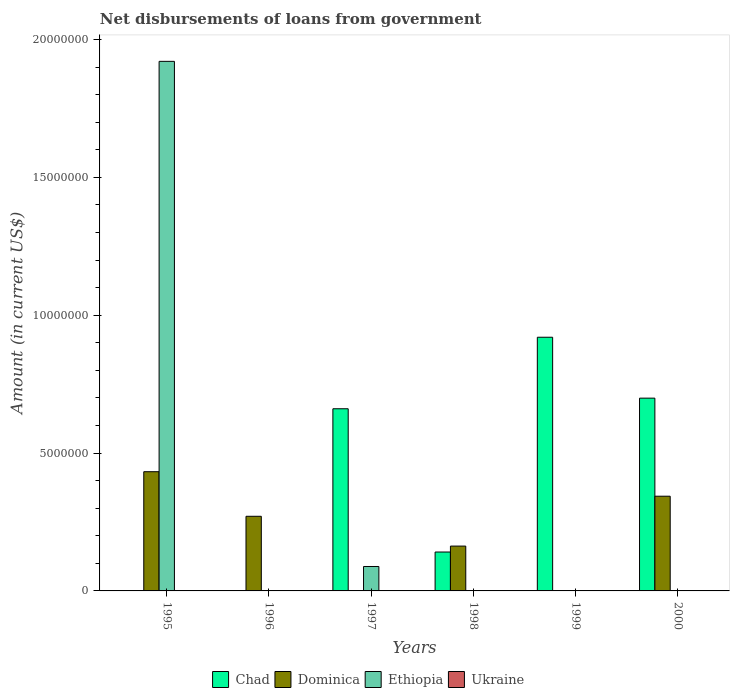Are the number of bars on each tick of the X-axis equal?
Offer a terse response. No. How many bars are there on the 3rd tick from the left?
Provide a short and direct response. 2. How many bars are there on the 1st tick from the right?
Ensure brevity in your answer.  2. What is the label of the 4th group of bars from the left?
Offer a terse response. 1998. What is the amount of loan disbursed from government in Chad in 1997?
Your answer should be compact. 6.61e+06. Across all years, what is the maximum amount of loan disbursed from government in Chad?
Keep it short and to the point. 9.20e+06. Across all years, what is the minimum amount of loan disbursed from government in Ethiopia?
Keep it short and to the point. 0. In which year was the amount of loan disbursed from government in Dominica maximum?
Make the answer very short. 1995. What is the total amount of loan disbursed from government in Ethiopia in the graph?
Make the answer very short. 2.01e+07. What is the difference between the amount of loan disbursed from government in Dominica in 1995 and that in 1996?
Provide a short and direct response. 1.62e+06. In the year 1995, what is the difference between the amount of loan disbursed from government in Ethiopia and amount of loan disbursed from government in Dominica?
Offer a terse response. 1.49e+07. What is the ratio of the amount of loan disbursed from government in Chad in 1999 to that in 2000?
Provide a succinct answer. 1.32. Is the amount of loan disbursed from government in Chad in 1997 less than that in 2000?
Make the answer very short. Yes. What is the difference between the highest and the second highest amount of loan disbursed from government in Dominica?
Provide a short and direct response. 8.89e+05. What is the difference between the highest and the lowest amount of loan disbursed from government in Chad?
Your answer should be very brief. 9.20e+06. Is it the case that in every year, the sum of the amount of loan disbursed from government in Dominica and amount of loan disbursed from government in Ukraine is greater than the sum of amount of loan disbursed from government in Ethiopia and amount of loan disbursed from government in Chad?
Make the answer very short. No. Is it the case that in every year, the sum of the amount of loan disbursed from government in Chad and amount of loan disbursed from government in Dominica is greater than the amount of loan disbursed from government in Ethiopia?
Keep it short and to the point. No. How many bars are there?
Your answer should be very brief. 10. Are all the bars in the graph horizontal?
Offer a very short reply. No. What is the difference between two consecutive major ticks on the Y-axis?
Your response must be concise. 5.00e+06. Does the graph contain any zero values?
Ensure brevity in your answer.  Yes. Where does the legend appear in the graph?
Your answer should be compact. Bottom center. How many legend labels are there?
Offer a terse response. 4. What is the title of the graph?
Ensure brevity in your answer.  Net disbursements of loans from government. Does "Faeroe Islands" appear as one of the legend labels in the graph?
Provide a short and direct response. No. What is the label or title of the Y-axis?
Ensure brevity in your answer.  Amount (in current US$). What is the Amount (in current US$) in Chad in 1995?
Offer a terse response. 0. What is the Amount (in current US$) of Dominica in 1995?
Give a very brief answer. 4.32e+06. What is the Amount (in current US$) of Ethiopia in 1995?
Make the answer very short. 1.92e+07. What is the Amount (in current US$) in Ukraine in 1995?
Your response must be concise. 0. What is the Amount (in current US$) of Chad in 1996?
Your answer should be very brief. 0. What is the Amount (in current US$) in Dominica in 1996?
Your answer should be very brief. 2.71e+06. What is the Amount (in current US$) in Ethiopia in 1996?
Make the answer very short. 0. What is the Amount (in current US$) of Chad in 1997?
Offer a terse response. 6.61e+06. What is the Amount (in current US$) of Ethiopia in 1997?
Give a very brief answer. 8.86e+05. What is the Amount (in current US$) of Ukraine in 1997?
Your answer should be very brief. 0. What is the Amount (in current US$) of Chad in 1998?
Offer a very short reply. 1.41e+06. What is the Amount (in current US$) in Dominica in 1998?
Ensure brevity in your answer.  1.63e+06. What is the Amount (in current US$) of Ukraine in 1998?
Provide a succinct answer. 0. What is the Amount (in current US$) of Chad in 1999?
Your response must be concise. 9.20e+06. What is the Amount (in current US$) of Ethiopia in 1999?
Provide a succinct answer. 0. What is the Amount (in current US$) in Chad in 2000?
Provide a short and direct response. 6.99e+06. What is the Amount (in current US$) of Dominica in 2000?
Offer a very short reply. 3.44e+06. What is the Amount (in current US$) of Ethiopia in 2000?
Provide a succinct answer. 0. What is the Amount (in current US$) of Ukraine in 2000?
Offer a terse response. 0. Across all years, what is the maximum Amount (in current US$) of Chad?
Ensure brevity in your answer.  9.20e+06. Across all years, what is the maximum Amount (in current US$) of Dominica?
Make the answer very short. 4.32e+06. Across all years, what is the maximum Amount (in current US$) of Ethiopia?
Provide a short and direct response. 1.92e+07. Across all years, what is the minimum Amount (in current US$) of Dominica?
Offer a very short reply. 0. Across all years, what is the minimum Amount (in current US$) of Ethiopia?
Provide a succinct answer. 0. What is the total Amount (in current US$) in Chad in the graph?
Keep it short and to the point. 2.42e+07. What is the total Amount (in current US$) of Dominica in the graph?
Make the answer very short. 1.21e+07. What is the total Amount (in current US$) of Ethiopia in the graph?
Give a very brief answer. 2.01e+07. What is the total Amount (in current US$) of Ukraine in the graph?
Your answer should be very brief. 0. What is the difference between the Amount (in current US$) in Dominica in 1995 and that in 1996?
Your answer should be very brief. 1.62e+06. What is the difference between the Amount (in current US$) of Ethiopia in 1995 and that in 1997?
Give a very brief answer. 1.83e+07. What is the difference between the Amount (in current US$) in Dominica in 1995 and that in 1998?
Your response must be concise. 2.70e+06. What is the difference between the Amount (in current US$) of Dominica in 1995 and that in 2000?
Your answer should be very brief. 8.89e+05. What is the difference between the Amount (in current US$) in Dominica in 1996 and that in 1998?
Offer a terse response. 1.08e+06. What is the difference between the Amount (in current US$) of Dominica in 1996 and that in 2000?
Offer a very short reply. -7.28e+05. What is the difference between the Amount (in current US$) in Chad in 1997 and that in 1998?
Your answer should be compact. 5.20e+06. What is the difference between the Amount (in current US$) in Chad in 1997 and that in 1999?
Provide a succinct answer. -2.59e+06. What is the difference between the Amount (in current US$) in Chad in 1997 and that in 2000?
Offer a very short reply. -3.85e+05. What is the difference between the Amount (in current US$) in Chad in 1998 and that in 1999?
Your answer should be compact. -7.79e+06. What is the difference between the Amount (in current US$) in Chad in 1998 and that in 2000?
Offer a terse response. -5.58e+06. What is the difference between the Amount (in current US$) of Dominica in 1998 and that in 2000?
Your answer should be very brief. -1.81e+06. What is the difference between the Amount (in current US$) of Chad in 1999 and that in 2000?
Provide a short and direct response. 2.21e+06. What is the difference between the Amount (in current US$) of Dominica in 1995 and the Amount (in current US$) of Ethiopia in 1997?
Make the answer very short. 3.44e+06. What is the difference between the Amount (in current US$) in Dominica in 1996 and the Amount (in current US$) in Ethiopia in 1997?
Your answer should be very brief. 1.82e+06. What is the difference between the Amount (in current US$) of Chad in 1997 and the Amount (in current US$) of Dominica in 1998?
Provide a succinct answer. 4.98e+06. What is the difference between the Amount (in current US$) of Chad in 1997 and the Amount (in current US$) of Dominica in 2000?
Ensure brevity in your answer.  3.17e+06. What is the difference between the Amount (in current US$) in Chad in 1998 and the Amount (in current US$) in Dominica in 2000?
Offer a very short reply. -2.02e+06. What is the difference between the Amount (in current US$) in Chad in 1999 and the Amount (in current US$) in Dominica in 2000?
Your response must be concise. 5.77e+06. What is the average Amount (in current US$) of Chad per year?
Make the answer very short. 4.04e+06. What is the average Amount (in current US$) in Dominica per year?
Provide a short and direct response. 2.02e+06. What is the average Amount (in current US$) of Ethiopia per year?
Keep it short and to the point. 3.35e+06. What is the average Amount (in current US$) in Ukraine per year?
Your answer should be compact. 0. In the year 1995, what is the difference between the Amount (in current US$) in Dominica and Amount (in current US$) in Ethiopia?
Make the answer very short. -1.49e+07. In the year 1997, what is the difference between the Amount (in current US$) of Chad and Amount (in current US$) of Ethiopia?
Your response must be concise. 5.72e+06. In the year 1998, what is the difference between the Amount (in current US$) of Chad and Amount (in current US$) of Dominica?
Give a very brief answer. -2.15e+05. In the year 2000, what is the difference between the Amount (in current US$) in Chad and Amount (in current US$) in Dominica?
Your answer should be very brief. 3.56e+06. What is the ratio of the Amount (in current US$) of Dominica in 1995 to that in 1996?
Give a very brief answer. 1.6. What is the ratio of the Amount (in current US$) in Ethiopia in 1995 to that in 1997?
Give a very brief answer. 21.68. What is the ratio of the Amount (in current US$) of Dominica in 1995 to that in 1998?
Your answer should be very brief. 2.66. What is the ratio of the Amount (in current US$) in Dominica in 1995 to that in 2000?
Provide a succinct answer. 1.26. What is the ratio of the Amount (in current US$) in Dominica in 1996 to that in 1998?
Provide a short and direct response. 1.66. What is the ratio of the Amount (in current US$) in Dominica in 1996 to that in 2000?
Your response must be concise. 0.79. What is the ratio of the Amount (in current US$) in Chad in 1997 to that in 1998?
Keep it short and to the point. 4.68. What is the ratio of the Amount (in current US$) of Chad in 1997 to that in 1999?
Your response must be concise. 0.72. What is the ratio of the Amount (in current US$) of Chad in 1997 to that in 2000?
Offer a terse response. 0.94. What is the ratio of the Amount (in current US$) of Chad in 1998 to that in 1999?
Offer a terse response. 0.15. What is the ratio of the Amount (in current US$) in Chad in 1998 to that in 2000?
Provide a succinct answer. 0.2. What is the ratio of the Amount (in current US$) of Dominica in 1998 to that in 2000?
Ensure brevity in your answer.  0.47. What is the ratio of the Amount (in current US$) in Chad in 1999 to that in 2000?
Offer a terse response. 1.32. What is the difference between the highest and the second highest Amount (in current US$) in Chad?
Your answer should be compact. 2.21e+06. What is the difference between the highest and the second highest Amount (in current US$) of Dominica?
Offer a very short reply. 8.89e+05. What is the difference between the highest and the lowest Amount (in current US$) in Chad?
Keep it short and to the point. 9.20e+06. What is the difference between the highest and the lowest Amount (in current US$) of Dominica?
Your answer should be compact. 4.32e+06. What is the difference between the highest and the lowest Amount (in current US$) in Ethiopia?
Your answer should be compact. 1.92e+07. 